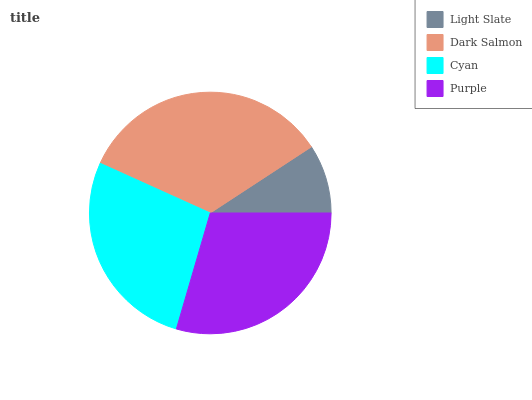Is Light Slate the minimum?
Answer yes or no. Yes. Is Dark Salmon the maximum?
Answer yes or no. Yes. Is Cyan the minimum?
Answer yes or no. No. Is Cyan the maximum?
Answer yes or no. No. Is Dark Salmon greater than Cyan?
Answer yes or no. Yes. Is Cyan less than Dark Salmon?
Answer yes or no. Yes. Is Cyan greater than Dark Salmon?
Answer yes or no. No. Is Dark Salmon less than Cyan?
Answer yes or no. No. Is Purple the high median?
Answer yes or no. Yes. Is Cyan the low median?
Answer yes or no. Yes. Is Cyan the high median?
Answer yes or no. No. Is Light Slate the low median?
Answer yes or no. No. 